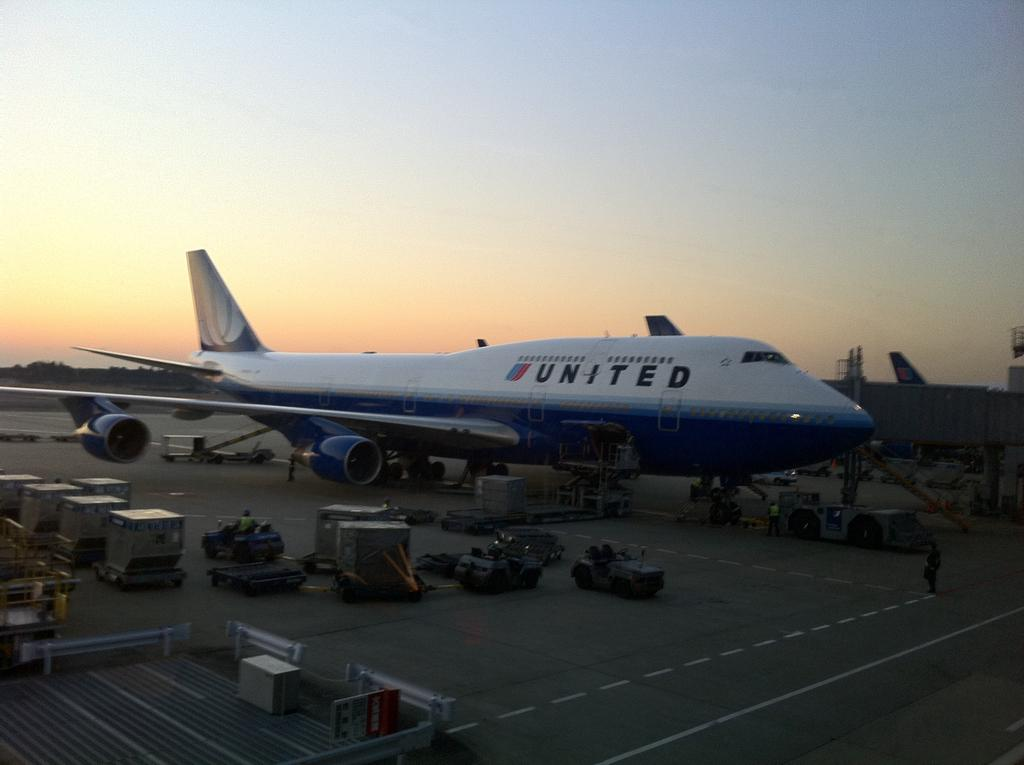<image>
Give a short and clear explanation of the subsequent image. the united plane is being loaded at the airport 